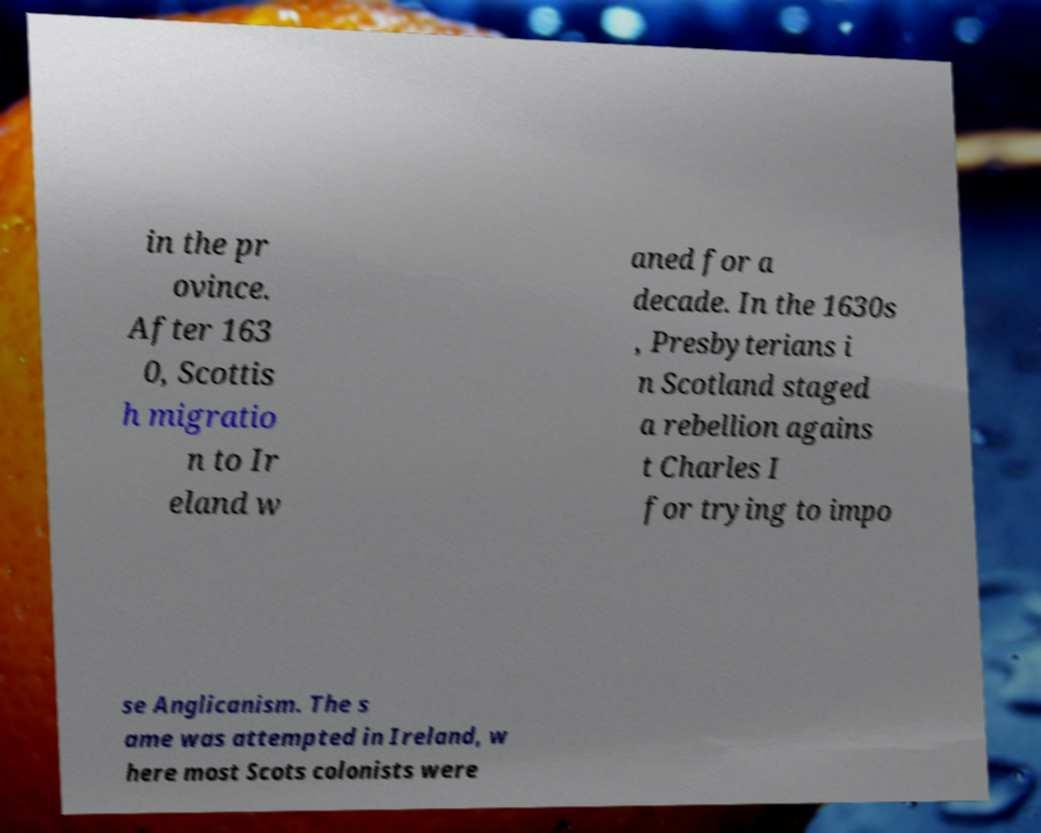Can you read and provide the text displayed in the image?This photo seems to have some interesting text. Can you extract and type it out for me? in the pr ovince. After 163 0, Scottis h migratio n to Ir eland w aned for a decade. In the 1630s , Presbyterians i n Scotland staged a rebellion agains t Charles I for trying to impo se Anglicanism. The s ame was attempted in Ireland, w here most Scots colonists were 